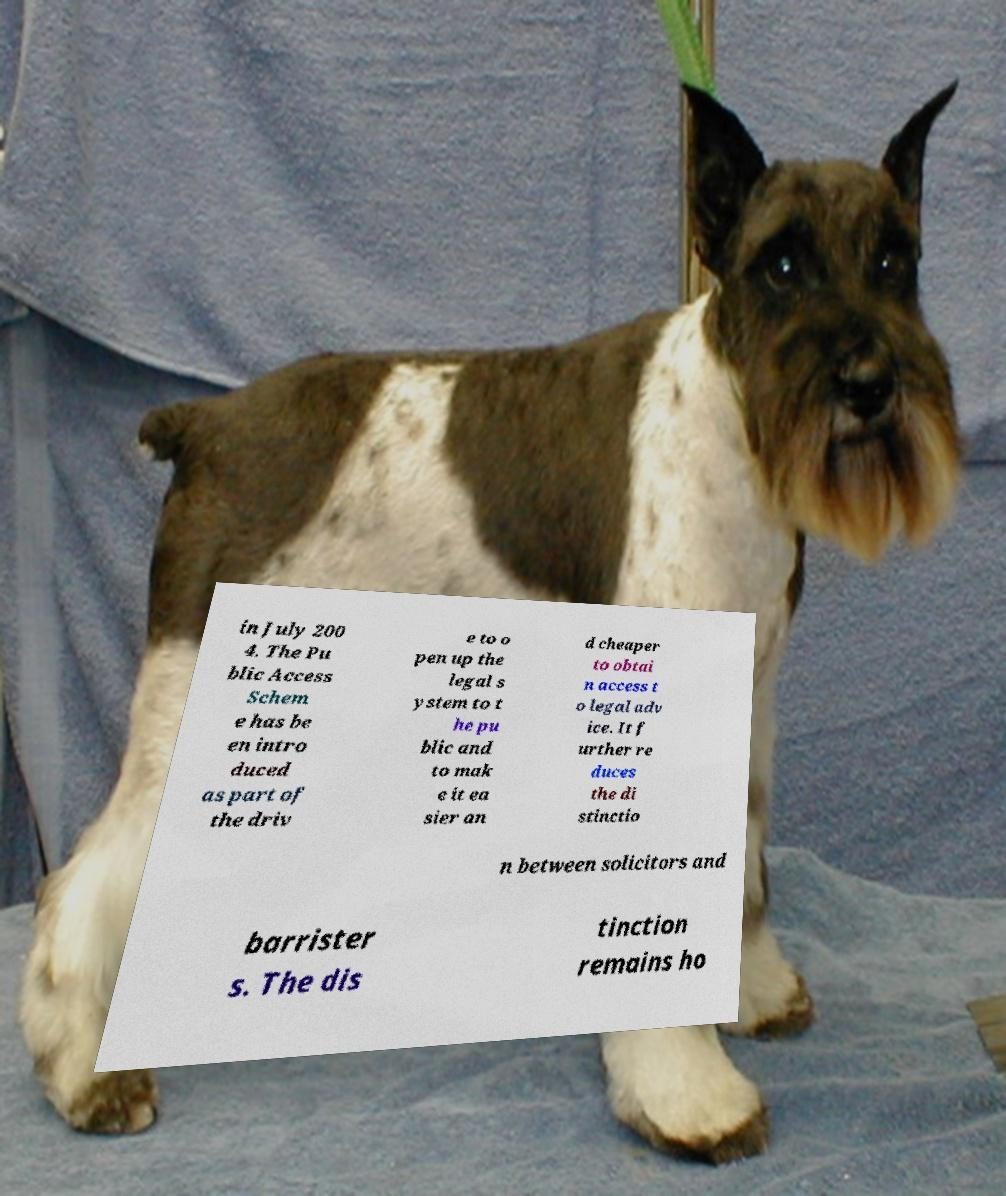There's text embedded in this image that I need extracted. Can you transcribe it verbatim? in July 200 4. The Pu blic Access Schem e has be en intro duced as part of the driv e to o pen up the legal s ystem to t he pu blic and to mak e it ea sier an d cheaper to obtai n access t o legal adv ice. It f urther re duces the di stinctio n between solicitors and barrister s. The dis tinction remains ho 